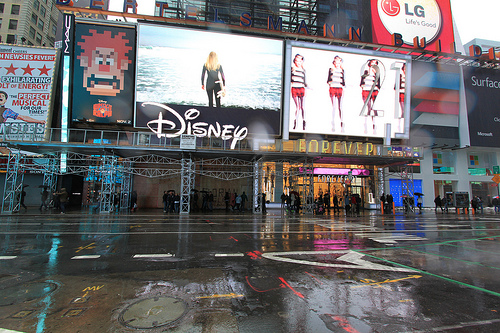<image>
Can you confirm if the woman is on the screen? Yes. Looking at the image, I can see the woman is positioned on top of the screen, with the screen providing support. Is the zebra crossing on the road? Yes. Looking at the image, I can see the zebra crossing is positioned on top of the road, with the road providing support. Is the people in front of the screen? No. The people is not in front of the screen. The spatial positioning shows a different relationship between these objects. 